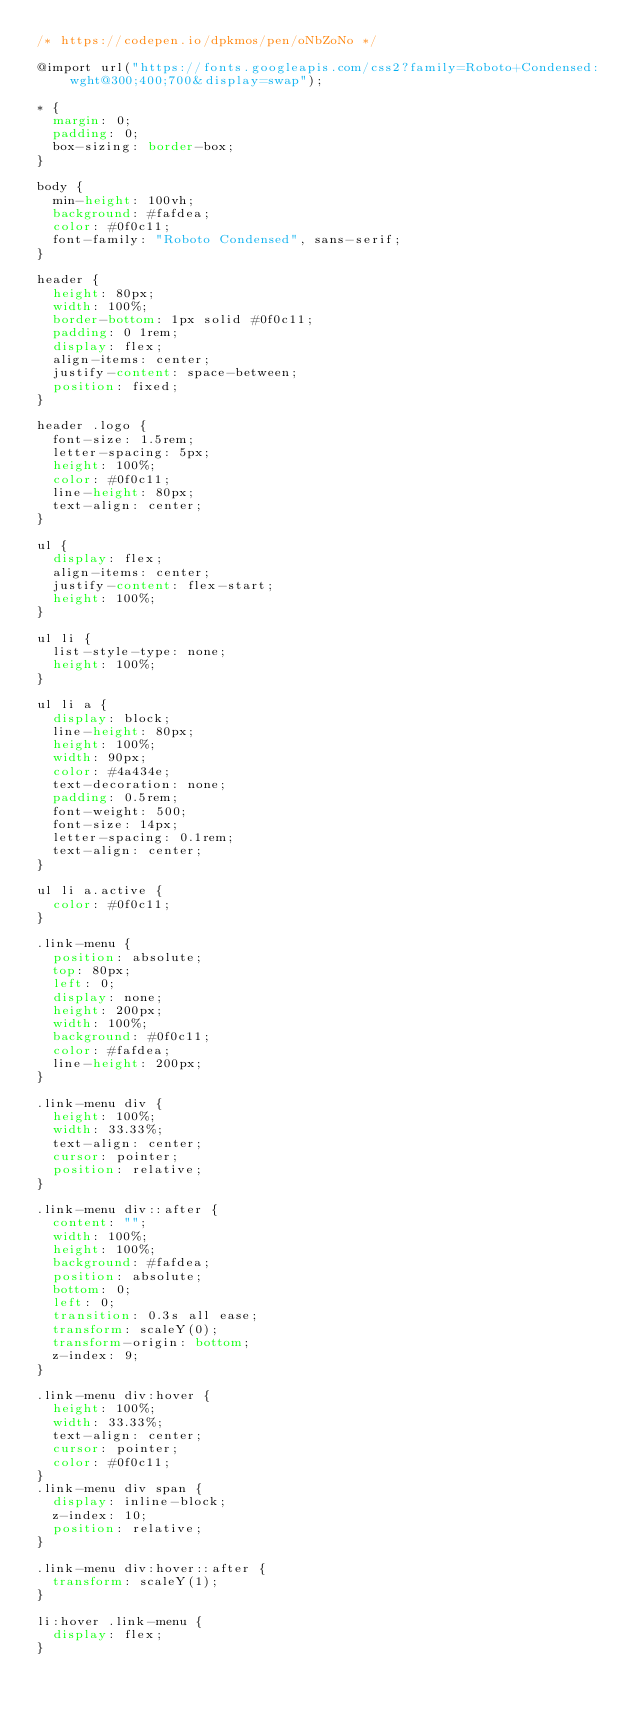<code> <loc_0><loc_0><loc_500><loc_500><_CSS_>/* https://codepen.io/dpkmos/pen/oNbZoNo */

@import url("https://fonts.googleapis.com/css2?family=Roboto+Condensed:wght@300;400;700&display=swap");

* {
  margin: 0;
  padding: 0;
  box-sizing: border-box;
}

body {
  min-height: 100vh;
  background: #fafdea;
  color: #0f0c11;
  font-family: "Roboto Condensed", sans-serif;
}

header {
  height: 80px;
  width: 100%;
  border-bottom: 1px solid #0f0c11;
  padding: 0 1rem;
  display: flex;
  align-items: center;
  justify-content: space-between;
  position: fixed;
}

header .logo {
  font-size: 1.5rem;
  letter-spacing: 5px;
  height: 100%;
  color: #0f0c11;
  line-height: 80px;
  text-align: center;
}

ul {
  display: flex;
  align-items: center;
  justify-content: flex-start;
  height: 100%;
}

ul li {
  list-style-type: none;
  height: 100%;
}

ul li a {
  display: block;
  line-height: 80px;
  height: 100%;
  width: 90px;
  color: #4a434e;
  text-decoration: none;
  padding: 0.5rem;
  font-weight: 500;
  font-size: 14px;
  letter-spacing: 0.1rem;
  text-align: center;
}

ul li a.active {
  color: #0f0c11;
}

.link-menu {
  position: absolute;
  top: 80px;
  left: 0;
  display: none;
  height: 200px;
  width: 100%;
  background: #0f0c11;
  color: #fafdea;
  line-height: 200px;
}

.link-menu div {
  height: 100%;
  width: 33.33%;
  text-align: center;
  cursor: pointer;
  position: relative;
}

.link-menu div::after {
  content: "";
  width: 100%;
  height: 100%;
  background: #fafdea;
  position: absolute;
  bottom: 0;
  left: 0;
  transition: 0.3s all ease;
  transform: scaleY(0);
  transform-origin: bottom;
  z-index: 9;
}

.link-menu div:hover {
  height: 100%;
  width: 33.33%;
  text-align: center;
  cursor: pointer;
  color: #0f0c11;
}
.link-menu div span {
  display: inline-block;
  z-index: 10;
  position: relative;
}

.link-menu div:hover::after {
  transform: scaleY(1);
}

li:hover .link-menu {
  display: flex;
}
</code> 